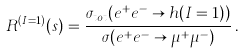<formula> <loc_0><loc_0><loc_500><loc_500>R ^ { ( I = 1 ) } ( s ) = \frac { \sigma _ { t o t } ( e ^ { + } e ^ { - } \to h ( I = 1 ) ) } { \sigma ( e ^ { + } e ^ { - } \to \mu ^ { + } \mu ^ { - } ) } \, .</formula> 